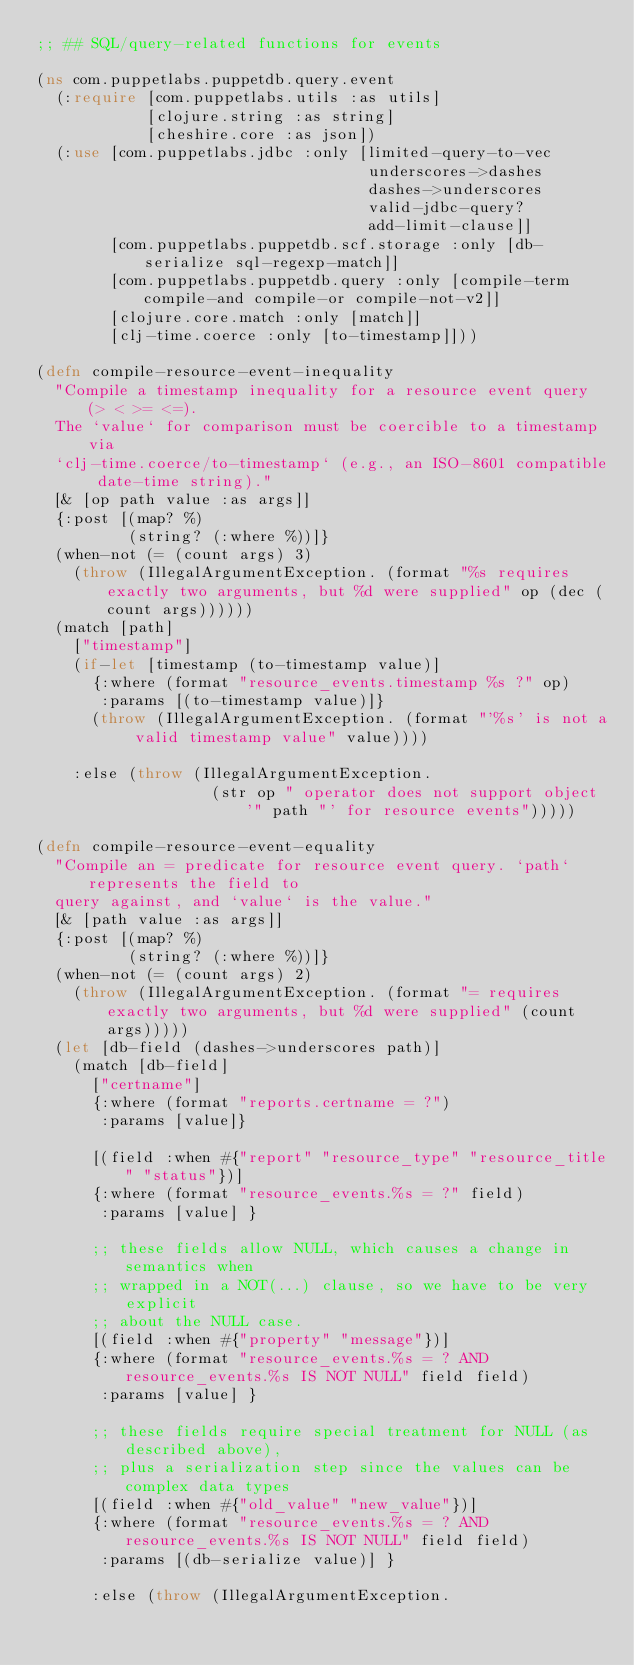Convert code to text. <code><loc_0><loc_0><loc_500><loc_500><_Clojure_>;; ## SQL/query-related functions for events

(ns com.puppetlabs.puppetdb.query.event
  (:require [com.puppetlabs.utils :as utils]
            [clojure.string :as string]
            [cheshire.core :as json])
  (:use [com.puppetlabs.jdbc :only [limited-query-to-vec
                                    underscores->dashes
                                    dashes->underscores
                                    valid-jdbc-query?
                                    add-limit-clause]]
        [com.puppetlabs.puppetdb.scf.storage :only [db-serialize sql-regexp-match]]
        [com.puppetlabs.puppetdb.query :only [compile-term compile-and compile-or compile-not-v2]]
        [clojure.core.match :only [match]]
        [clj-time.coerce :only [to-timestamp]]))

(defn compile-resource-event-inequality
  "Compile a timestamp inequality for a resource event query (> < >= <=).
  The `value` for comparison must be coercible to a timestamp via
  `clj-time.coerce/to-timestamp` (e.g., an ISO-8601 compatible date-time string)."
  [& [op path value :as args]]
  {:post [(map? %)
          (string? (:where %))]}
  (when-not (= (count args) 3)
    (throw (IllegalArgumentException. (format "%s requires exactly two arguments, but %d were supplied" op (dec (count args))))))
  (match [path]
    ["timestamp"]
    (if-let [timestamp (to-timestamp value)]
      {:where (format "resource_events.timestamp %s ?" op)
       :params [(to-timestamp value)]}
      (throw (IllegalArgumentException. (format "'%s' is not a valid timestamp value" value))))

    :else (throw (IllegalArgumentException.
                   (str op " operator does not support object '" path "' for resource events")))))

(defn compile-resource-event-equality
  "Compile an = predicate for resource event query. `path` represents the field to
  query against, and `value` is the value."
  [& [path value :as args]]
  {:post [(map? %)
          (string? (:where %))]}
  (when-not (= (count args) 2)
    (throw (IllegalArgumentException. (format "= requires exactly two arguments, but %d were supplied" (count args)))))
  (let [db-field (dashes->underscores path)]
    (match [db-field]
      ["certname"]
      {:where (format "reports.certname = ?")
       :params [value]}

      [(field :when #{"report" "resource_type" "resource_title" "status"})]
      {:where (format "resource_events.%s = ?" field)
       :params [value] }

      ;; these fields allow NULL, which causes a change in semantics when
      ;; wrapped in a NOT(...) clause, so we have to be very explicit
      ;; about the NULL case.
      [(field :when #{"property" "message"})]
      {:where (format "resource_events.%s = ? AND resource_events.%s IS NOT NULL" field field)
       :params [value] }

      ;; these fields require special treatment for NULL (as described above),
      ;; plus a serialization step since the values can be complex data types
      [(field :when #{"old_value" "new_value"})]
      {:where (format "resource_events.%s = ? AND resource_events.%s IS NOT NULL" field field)
       :params [(db-serialize value)] }

      :else (throw (IllegalArgumentException.</code> 